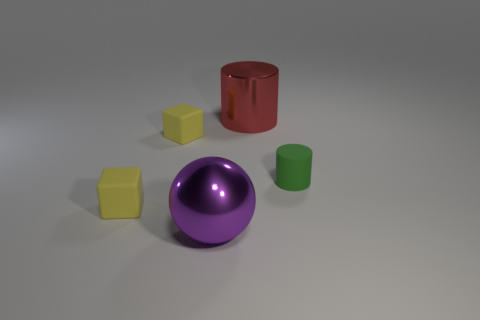Are there any other small things that have the same material as the purple thing?
Give a very brief answer. No. Is the number of balls behind the purple metal sphere greater than the number of large red objects left of the tiny green matte thing?
Offer a very short reply. No. Is the green matte object the same size as the purple sphere?
Offer a very short reply. No. What color is the small object to the left of the yellow cube behind the small green rubber thing?
Keep it short and to the point. Yellow. What is the color of the matte cylinder?
Give a very brief answer. Green. Is there a metallic object that has the same color as the tiny matte cylinder?
Offer a terse response. No. Is the color of the shiny object that is in front of the red cylinder the same as the large shiny cylinder?
Make the answer very short. No. What number of objects are either metallic objects to the right of the big purple ball or tiny cyan rubber blocks?
Offer a very short reply. 1. Are there any yellow things in front of the green matte cylinder?
Offer a very short reply. Yes. Do the object that is to the right of the red shiny cylinder and the big cylinder have the same material?
Offer a very short reply. No. 